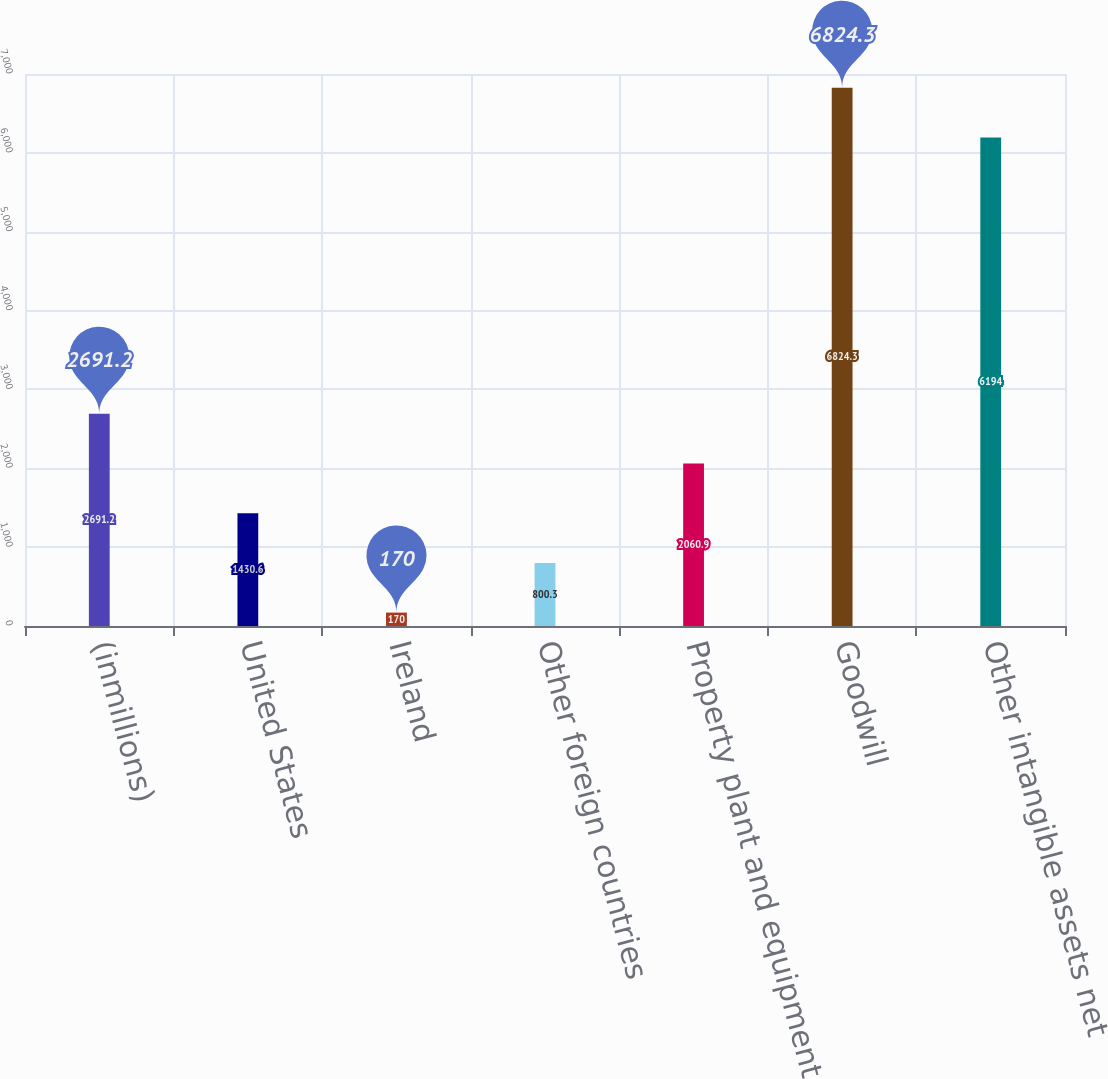Convert chart to OTSL. <chart><loc_0><loc_0><loc_500><loc_500><bar_chart><fcel>(inmillions)<fcel>United States<fcel>Ireland<fcel>Other foreign countries<fcel>Property plant and equipment<fcel>Goodwill<fcel>Other intangible assets net<nl><fcel>2691.2<fcel>1430.6<fcel>170<fcel>800.3<fcel>2060.9<fcel>6824.3<fcel>6194<nl></chart> 